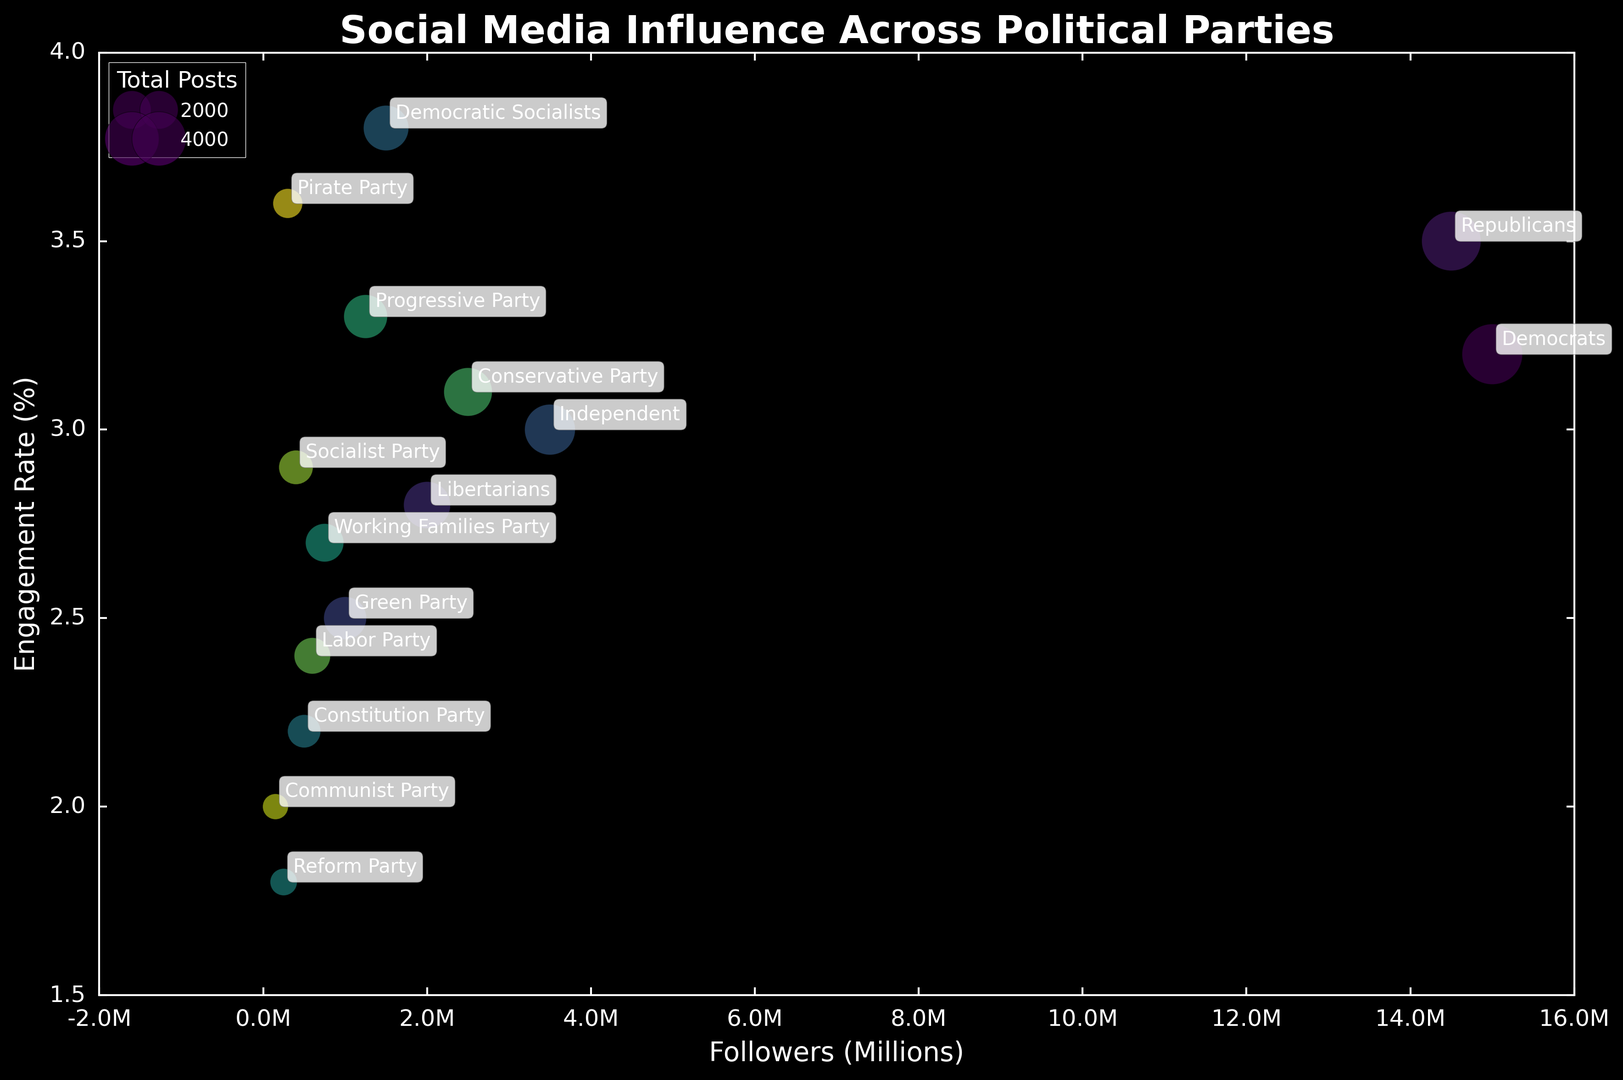Which political party has the highest engagement rate? Look at the y-axis (Engagement Rate) and identify the party with the highest value. The Democratic Socialists have the highest engagement rate of 3.8%.
Answer: Democratic Socialists Which party has the lowest follower count? Observing the x-axis (Followers), we find the Communist Party has the lowest follower count at 150,000.
Answer: Communist Party How many political parties have an engagement rate above 3%? Check the y-axis and count the number of parties that have an engagement rate above the 3% mark. The parties are Democrats, Republicans, Independent, Democratic Socialists, Progressive Party, and Pirate Party, making a total of 6.
Answer: 6 Compare the follower count and engagement rate of Democrats and Republicans. Who has more followers and who has a higher engagement rate? Democrats have 15 million followers while Republicans have 14.5 million followers, so Democrats have more followers. For engagement rate, Republicans have a rate of 3.5%, while Democrats have 3.2%, meaning Republicans have a higher engagement rate.
Answer: Democrats have more followers, Republicans have a higher engagement rate What is the visual difference in bubble sizes between the Democrats and the Green Party? By comparing the size of the bubbles associated with each party, it's evident that the Democrats' bubble is significantly larger than the Green Party's bubble, indicating more total posts.
Answer: Democrats' bubble is significantly larger Which party lies closest to the center of the plot in terms of followers and engagement rate? The center can be roughly estimated. Independent, with 3.5 million followers and a 3.0% engagement rate, appears close to this center.
Answer: Independent How does the engagement rate of the Libertarians compare to that of the Progressive Party? The Libertarians have an engagement rate of 2.8%, while the Progressive Party has a rate of 3.3%. Thus, the Progressive Party has a higher engagement rate.
Answer: Progressive Party has a higher engagement rate What is the sum of followers for the Green Party and the Socialist Party? Green Party has 1 million followers and the Socialist Party has 400,000 followers. Summing these values gives 1,000,000 + 400,000 = 1,400,000.
Answer: 1,400,000 Which party has the largest bubble size and what does it indicate? Observe the size of the bubbles to find the largest one. The Democrats' bubble is the largest, indicating they have posted the most on social media (5,000 posts).
Answer: Democrats, most posts 